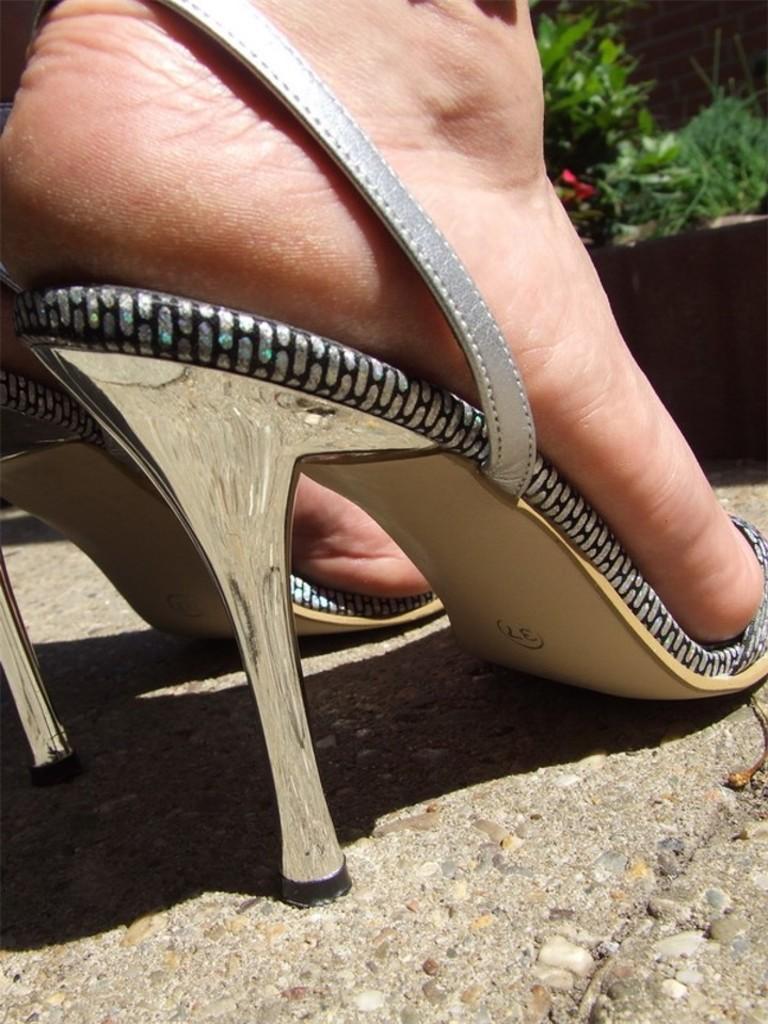In one or two sentences, can you explain what this image depicts? This image is of a lady wearing heels. 